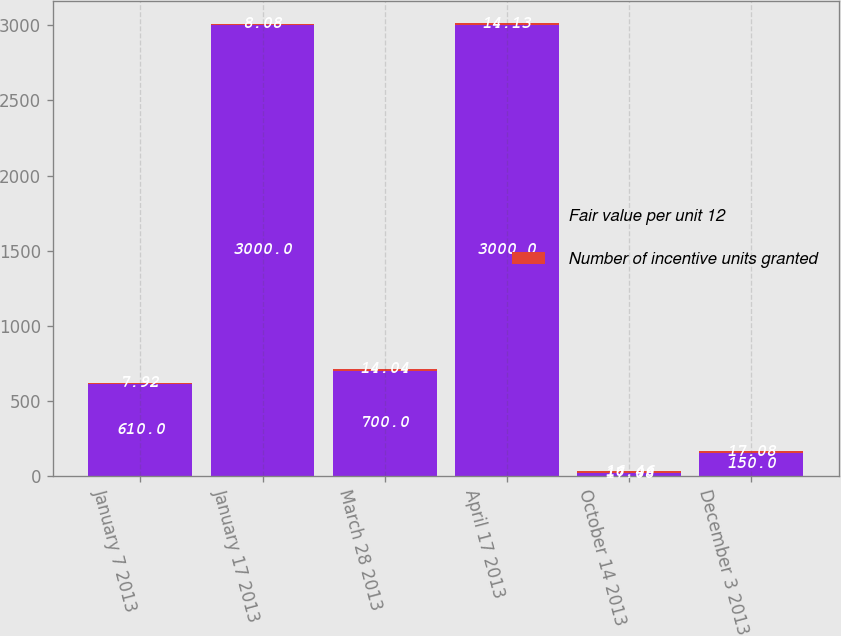Convert chart to OTSL. <chart><loc_0><loc_0><loc_500><loc_500><stacked_bar_chart><ecel><fcel>January 7 2013<fcel>January 17 2013<fcel>March 28 2013<fcel>April 17 2013<fcel>October 14 2013<fcel>December 3 2013<nl><fcel>Fair value per unit 12<fcel>610<fcel>3000<fcel>700<fcel>3000<fcel>17.08<fcel>150<nl><fcel>Number of incentive units granted<fcel>7.92<fcel>8.08<fcel>14.04<fcel>14.13<fcel>16.46<fcel>17.08<nl></chart> 